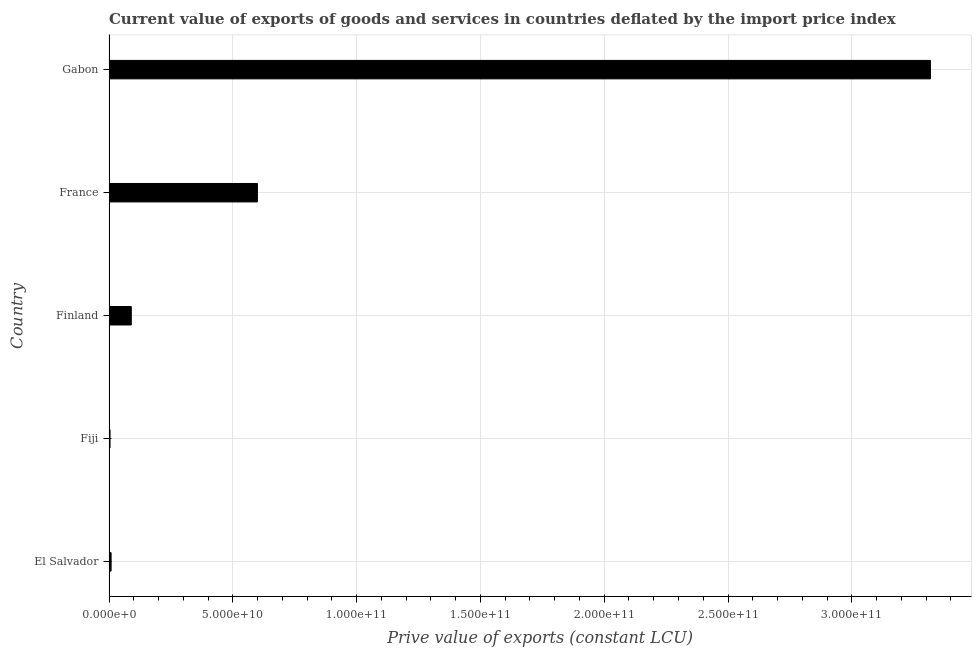Does the graph contain grids?
Provide a succinct answer. Yes. What is the title of the graph?
Ensure brevity in your answer.  Current value of exports of goods and services in countries deflated by the import price index. What is the label or title of the X-axis?
Your answer should be compact. Prive value of exports (constant LCU). What is the price value of exports in El Salvador?
Make the answer very short. 8.40e+08. Across all countries, what is the maximum price value of exports?
Your answer should be compact. 3.32e+11. Across all countries, what is the minimum price value of exports?
Offer a very short reply. 4.08e+08. In which country was the price value of exports maximum?
Your answer should be compact. Gabon. In which country was the price value of exports minimum?
Your answer should be compact. Fiji. What is the sum of the price value of exports?
Your response must be concise. 4.02e+11. What is the difference between the price value of exports in Finland and France?
Offer a very short reply. -5.09e+1. What is the average price value of exports per country?
Make the answer very short. 8.04e+1. What is the median price value of exports?
Ensure brevity in your answer.  9.00e+09. In how many countries, is the price value of exports greater than 120000000000 LCU?
Your response must be concise. 1. What is the ratio of the price value of exports in Fiji to that in France?
Your response must be concise. 0.01. Is the difference between the price value of exports in Fiji and Finland greater than the difference between any two countries?
Make the answer very short. No. What is the difference between the highest and the second highest price value of exports?
Give a very brief answer. 2.72e+11. What is the difference between the highest and the lowest price value of exports?
Provide a short and direct response. 3.31e+11. How many bars are there?
Keep it short and to the point. 5. What is the difference between two consecutive major ticks on the X-axis?
Offer a very short reply. 5.00e+1. What is the Prive value of exports (constant LCU) of El Salvador?
Offer a terse response. 8.40e+08. What is the Prive value of exports (constant LCU) of Fiji?
Offer a terse response. 4.08e+08. What is the Prive value of exports (constant LCU) in Finland?
Your response must be concise. 9.00e+09. What is the Prive value of exports (constant LCU) in France?
Provide a short and direct response. 5.99e+1. What is the Prive value of exports (constant LCU) of Gabon?
Offer a terse response. 3.32e+11. What is the difference between the Prive value of exports (constant LCU) in El Salvador and Fiji?
Give a very brief answer. 4.32e+08. What is the difference between the Prive value of exports (constant LCU) in El Salvador and Finland?
Keep it short and to the point. -8.16e+09. What is the difference between the Prive value of exports (constant LCU) in El Salvador and France?
Keep it short and to the point. -5.91e+1. What is the difference between the Prive value of exports (constant LCU) in El Salvador and Gabon?
Give a very brief answer. -3.31e+11. What is the difference between the Prive value of exports (constant LCU) in Fiji and Finland?
Give a very brief answer. -8.59e+09. What is the difference between the Prive value of exports (constant LCU) in Fiji and France?
Keep it short and to the point. -5.95e+1. What is the difference between the Prive value of exports (constant LCU) in Fiji and Gabon?
Provide a short and direct response. -3.31e+11. What is the difference between the Prive value of exports (constant LCU) in Finland and France?
Ensure brevity in your answer.  -5.09e+1. What is the difference between the Prive value of exports (constant LCU) in Finland and Gabon?
Make the answer very short. -3.23e+11. What is the difference between the Prive value of exports (constant LCU) in France and Gabon?
Keep it short and to the point. -2.72e+11. What is the ratio of the Prive value of exports (constant LCU) in El Salvador to that in Fiji?
Your answer should be compact. 2.06. What is the ratio of the Prive value of exports (constant LCU) in El Salvador to that in Finland?
Your response must be concise. 0.09. What is the ratio of the Prive value of exports (constant LCU) in El Salvador to that in France?
Keep it short and to the point. 0.01. What is the ratio of the Prive value of exports (constant LCU) in El Salvador to that in Gabon?
Give a very brief answer. 0. What is the ratio of the Prive value of exports (constant LCU) in Fiji to that in Finland?
Your answer should be compact. 0.04. What is the ratio of the Prive value of exports (constant LCU) in Fiji to that in France?
Provide a short and direct response. 0.01. What is the ratio of the Prive value of exports (constant LCU) in Fiji to that in Gabon?
Your answer should be very brief. 0. What is the ratio of the Prive value of exports (constant LCU) in Finland to that in Gabon?
Make the answer very short. 0.03. What is the ratio of the Prive value of exports (constant LCU) in France to that in Gabon?
Your answer should be compact. 0.18. 